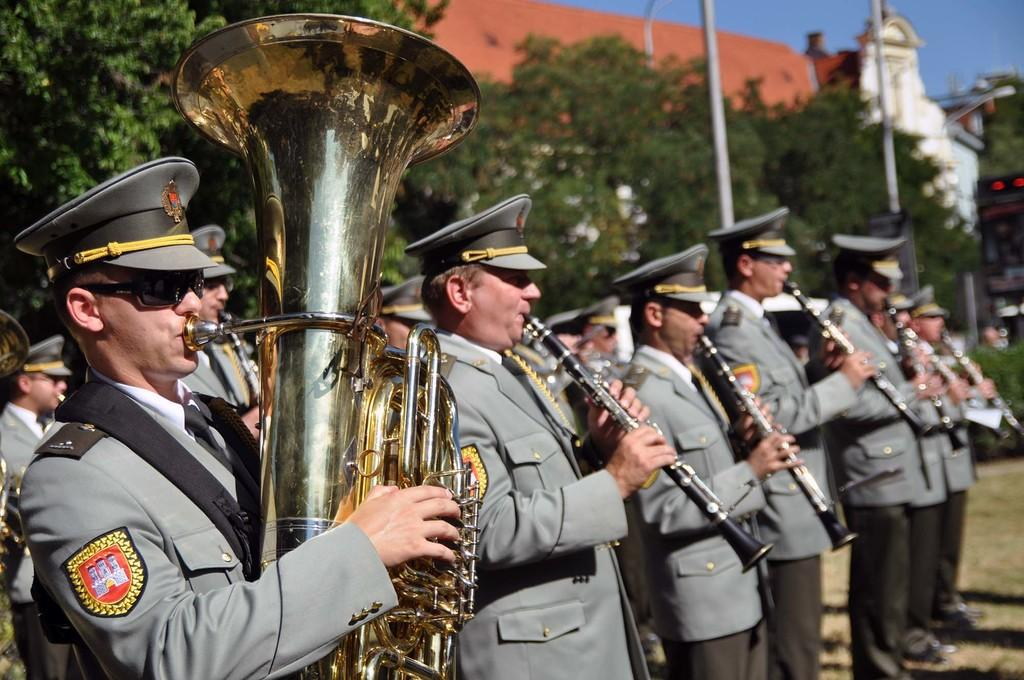What are the people in the image holding? The people in the image are holding clarinets and a tuba. What can be seen in the background of the image? There are trees, poles, at least one building, and the sky visible in the background of the image. What type of paper is the minister holding in the image? There is no minister or paper present in the image. What kind of pain is the group of people experiencing in the image? There is no indication of pain or discomfort in the image; the people are holding musical instruments. 